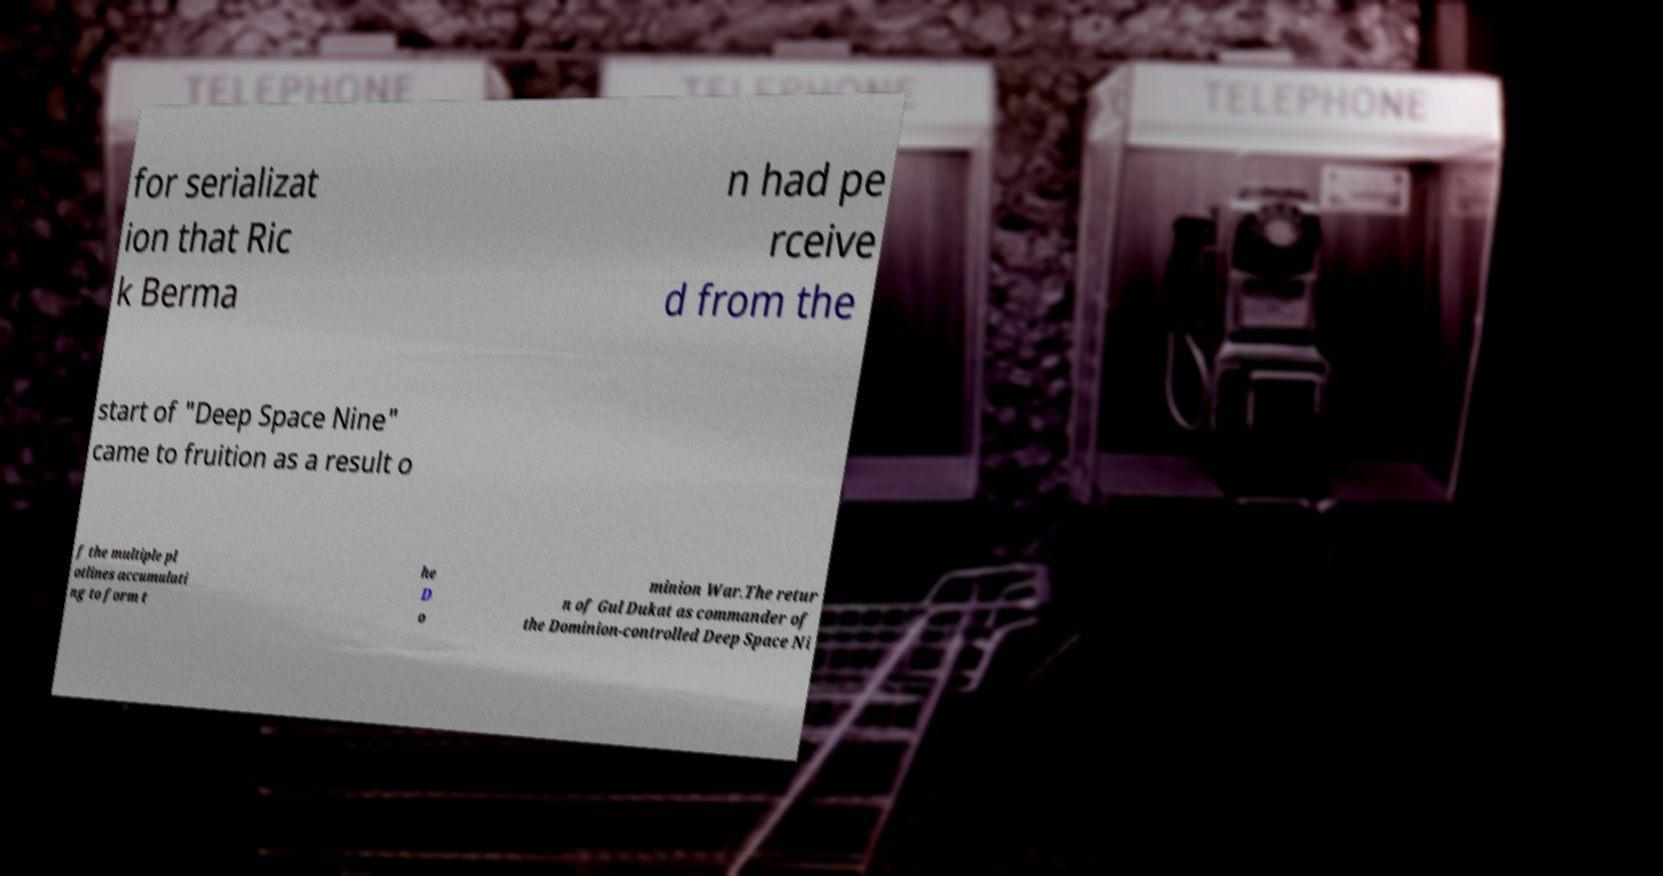There's text embedded in this image that I need extracted. Can you transcribe it verbatim? for serializat ion that Ric k Berma n had pe rceive d from the start of "Deep Space Nine" came to fruition as a result o f the multiple pl otlines accumulati ng to form t he D o minion War.The retur n of Gul Dukat as commander of the Dominion-controlled Deep Space Ni 